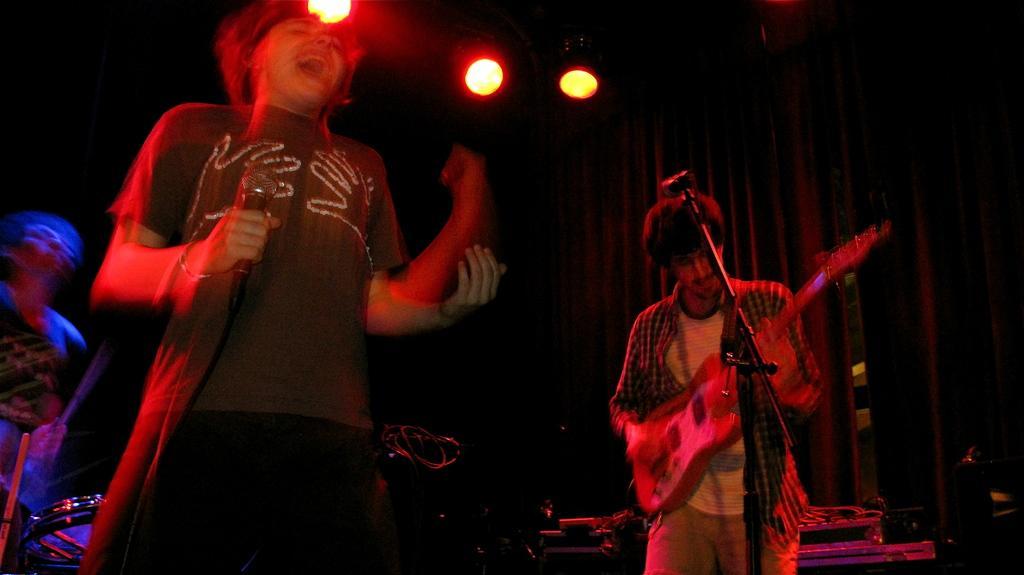In one or two sentences, can you explain what this image depicts? In the middle of the image few people are standing and holding some musical instruments and microphone. Behind them there is cloth. At the top of the image there are some lights. 